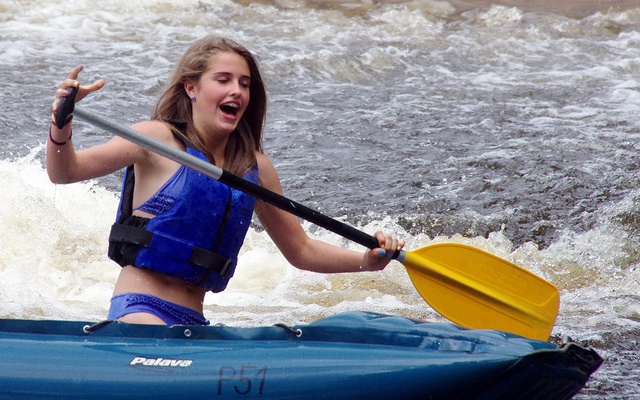Describe the objects in this image and their specific colors. I can see people in lightgray, black, navy, brown, and maroon tones and boat in lightgray, navy, teal, and gray tones in this image. 